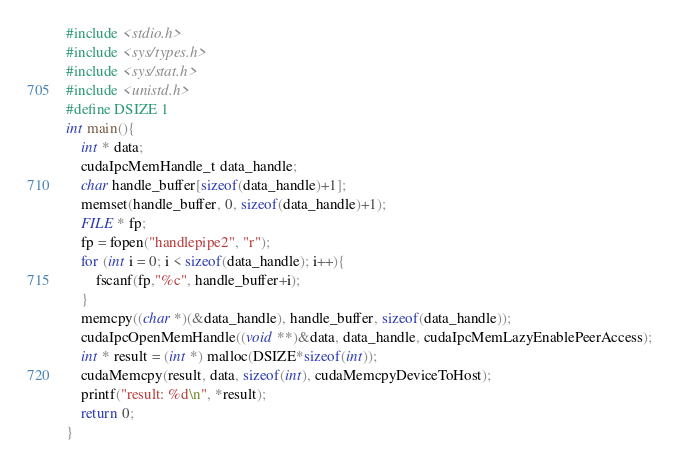<code> <loc_0><loc_0><loc_500><loc_500><_Cuda_>#include <stdio.h>
#include <sys/types.h>
#include <sys/stat.h>
#include <unistd.h>
#define DSIZE 1
int main(){
	int * data;
	cudaIpcMemHandle_t data_handle;
	char handle_buffer[sizeof(data_handle)+1];
	memset(handle_buffer, 0, sizeof(data_handle)+1);
	FILE * fp;
	fp = fopen("handlepipe2", "r");
	for (int i = 0; i < sizeof(data_handle); i++){
		fscanf(fp,"%c", handle_buffer+i);
	}
	memcpy((char *)(&data_handle), handle_buffer, sizeof(data_handle));
	cudaIpcOpenMemHandle((void **)&data, data_handle, cudaIpcMemLazyEnablePeerAccess);
	int * result = (int *) malloc(DSIZE*sizeof(int));
	cudaMemcpy(result, data, sizeof(int), cudaMemcpyDeviceToHost);
	printf("result: %d\n", *result);
	return 0;
}
</code> 